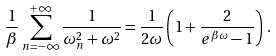<formula> <loc_0><loc_0><loc_500><loc_500>\frac { 1 } { \beta } \sum _ { n = - \infty } ^ { + \infty } \frac { 1 } { \omega _ { n } ^ { 2 } + \omega ^ { 2 } } = \frac { 1 } { 2 \omega } \left ( 1 + \frac { 2 } { e ^ { \beta \omega } - 1 } \right ) \, .</formula> 